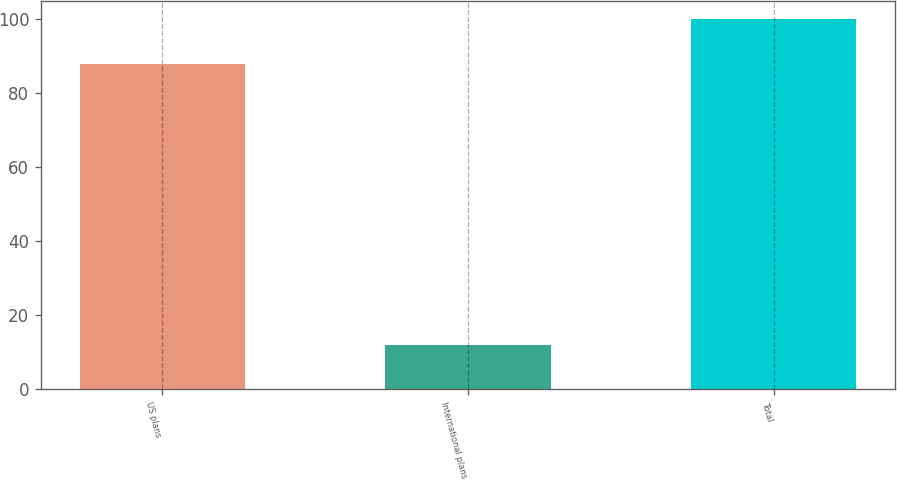Convert chart to OTSL. <chart><loc_0><loc_0><loc_500><loc_500><bar_chart><fcel>US plans<fcel>International plans<fcel>Total<nl><fcel>88<fcel>12<fcel>100<nl></chart> 